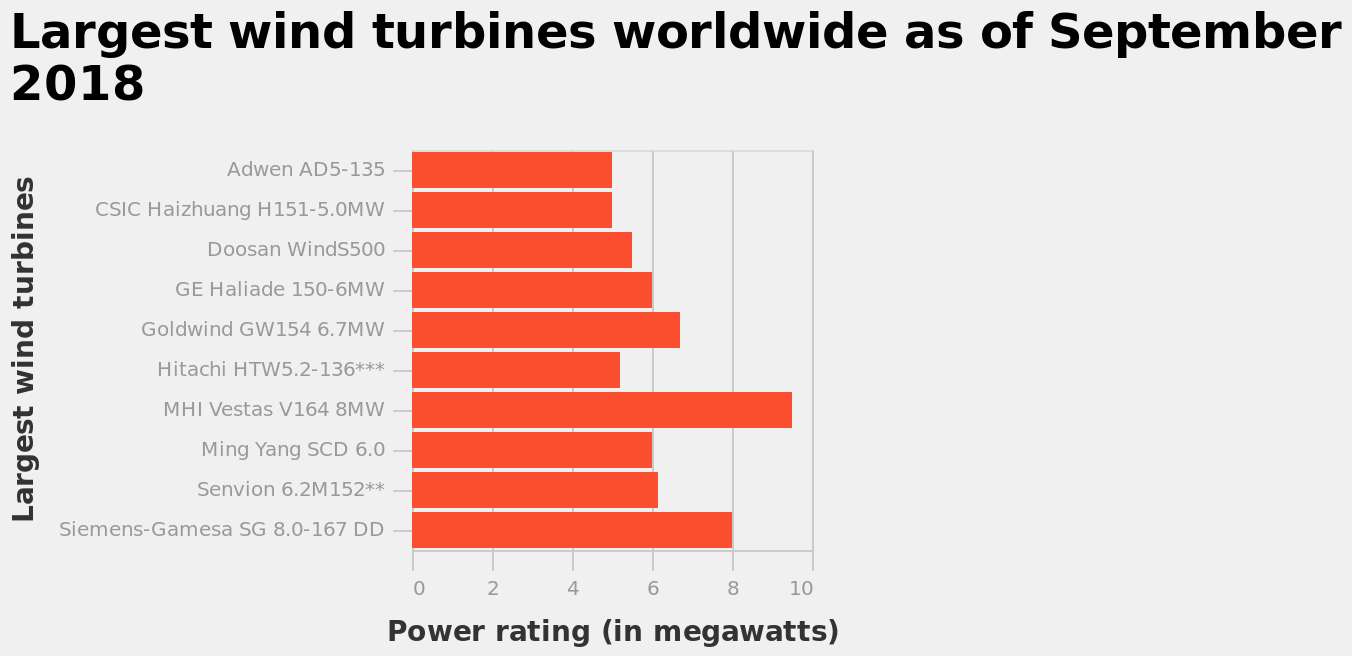<image>
How many wind turbines are included in the top 10 largest wind turbines worldwide? The top 10 largest wind turbines worldwide include at least 10 wind turbines. 